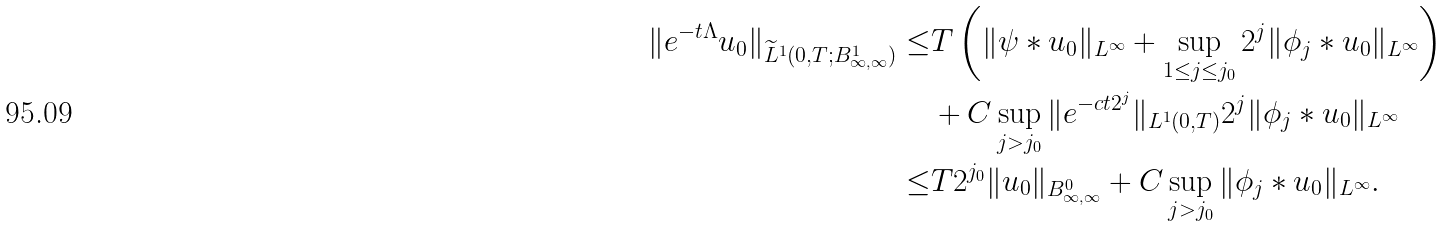<formula> <loc_0><loc_0><loc_500><loc_500>\| e ^ { - t \Lambda } u _ { 0 } \| _ { \widetilde { L } ^ { 1 } ( 0 , T ; B ^ { 1 } _ { \infty , \infty } ) } \leq & T \left ( \| \psi * u _ { 0 } \| _ { L ^ { \infty } } + \sup _ { 1 \leq j \leq j _ { 0 } } 2 ^ { j } \| \phi _ { j } * u _ { 0 } \| _ { L ^ { \infty } } \right ) \\ & + C \sup _ { j > j _ { 0 } } \| e ^ { - c t 2 ^ { j } } \| _ { L ^ { 1 } ( 0 , T ) } 2 ^ { j } \| \phi _ { j } * u _ { 0 } \| _ { L ^ { \infty } } \\ \leq & T 2 ^ { j _ { 0 } } \| u _ { 0 } \| _ { B ^ { 0 } _ { \infty , \infty } } + C \sup _ { j > j _ { 0 } } \| \phi _ { j } * u _ { 0 } \| _ { L ^ { \infty } } .</formula> 